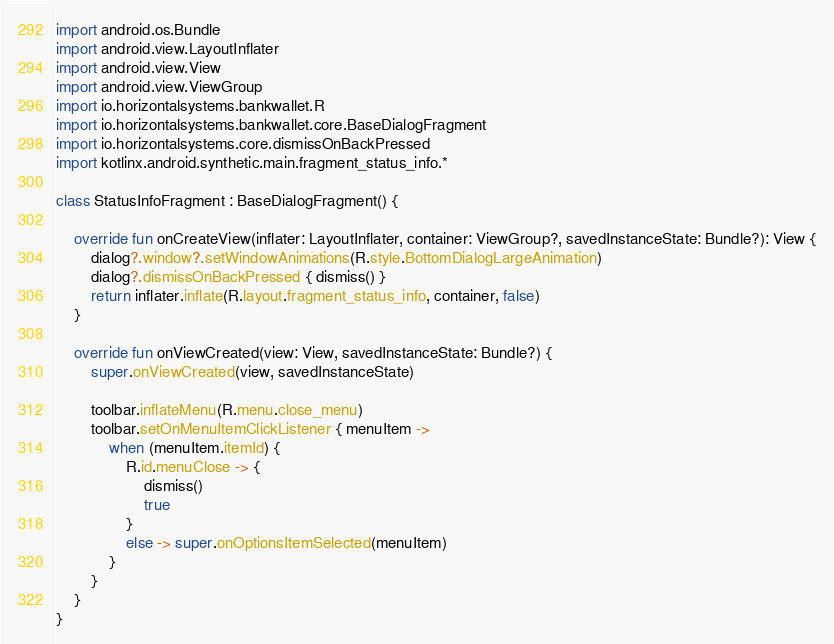<code> <loc_0><loc_0><loc_500><loc_500><_Kotlin_>
import android.os.Bundle
import android.view.LayoutInflater
import android.view.View
import android.view.ViewGroup
import io.horizontalsystems.bankwallet.R
import io.horizontalsystems.bankwallet.core.BaseDialogFragment
import io.horizontalsystems.core.dismissOnBackPressed
import kotlinx.android.synthetic.main.fragment_status_info.*

class StatusInfoFragment : BaseDialogFragment() {

    override fun onCreateView(inflater: LayoutInflater, container: ViewGroup?, savedInstanceState: Bundle?): View {
        dialog?.window?.setWindowAnimations(R.style.BottomDialogLargeAnimation)
        dialog?.dismissOnBackPressed { dismiss() }
        return inflater.inflate(R.layout.fragment_status_info, container, false)
    }

    override fun onViewCreated(view: View, savedInstanceState: Bundle?) {
        super.onViewCreated(view, savedInstanceState)

        toolbar.inflateMenu(R.menu.close_menu)
        toolbar.setOnMenuItemClickListener { menuItem ->
            when (menuItem.itemId) {
                R.id.menuClose -> {
                    dismiss()
                    true
                }
                else -> super.onOptionsItemSelected(menuItem)
            }
        }
    }
}
</code> 